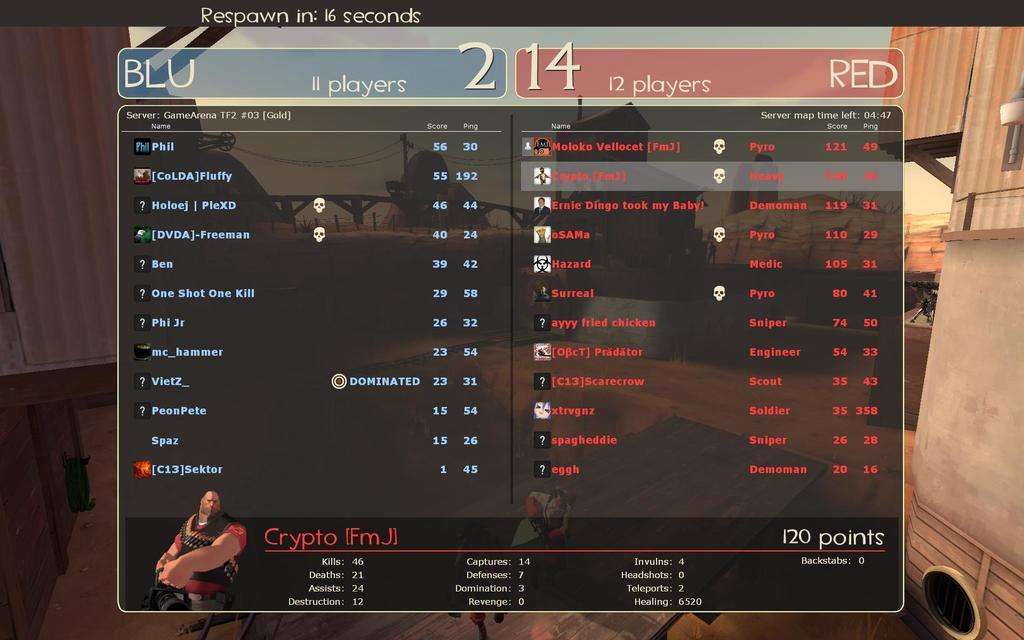<image>
Present a compact description of the photo's key features. Screen showing the score from a game which a respawn at 16 seconds. 